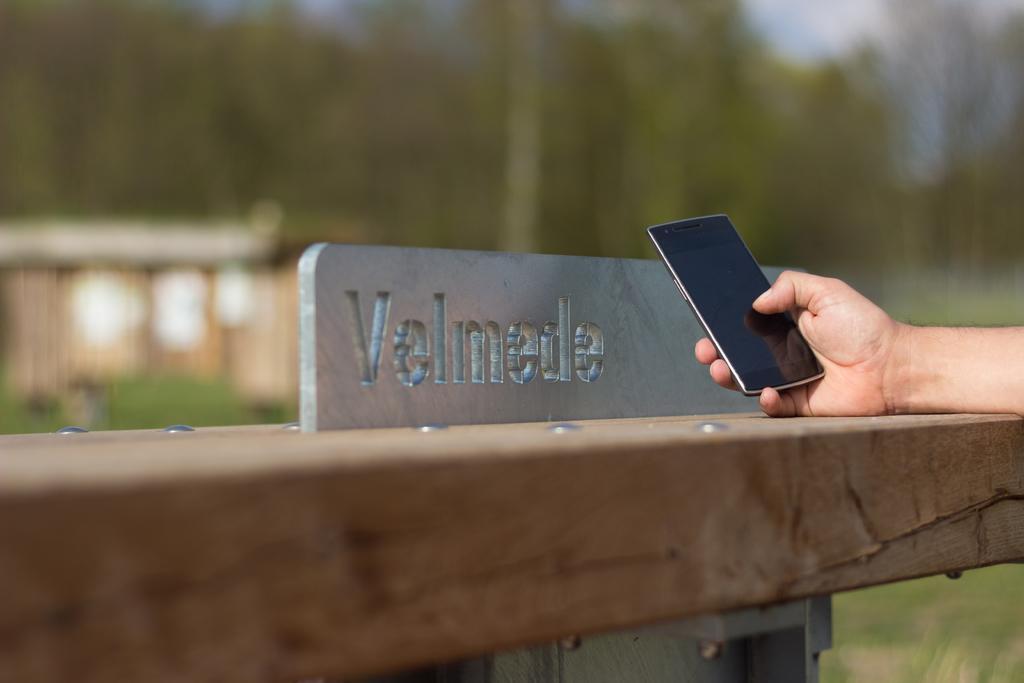Describe this image in one or two sentences. As we can see in the image there is a human hand holding mobile phone. In the background there are trees. 